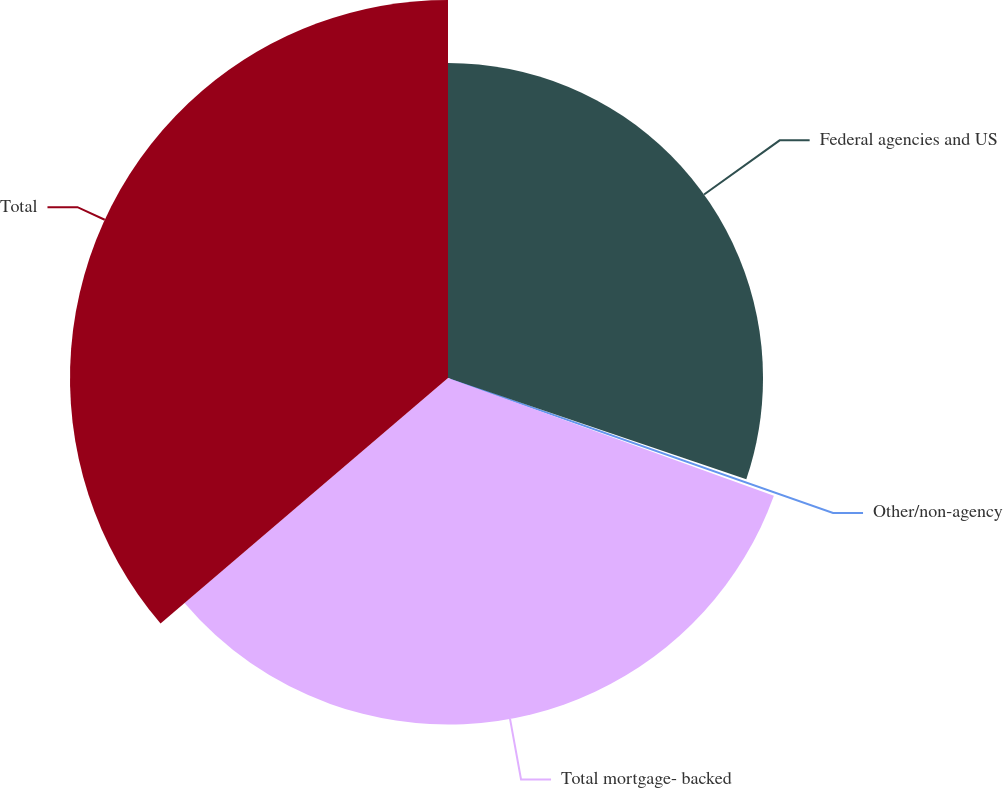<chart> <loc_0><loc_0><loc_500><loc_500><pie_chart><fcel>Federal agencies and US<fcel>Other/non-agency<fcel>Total mortgage- backed<fcel>Total<nl><fcel>30.21%<fcel>0.31%<fcel>33.23%<fcel>36.25%<nl></chart> 